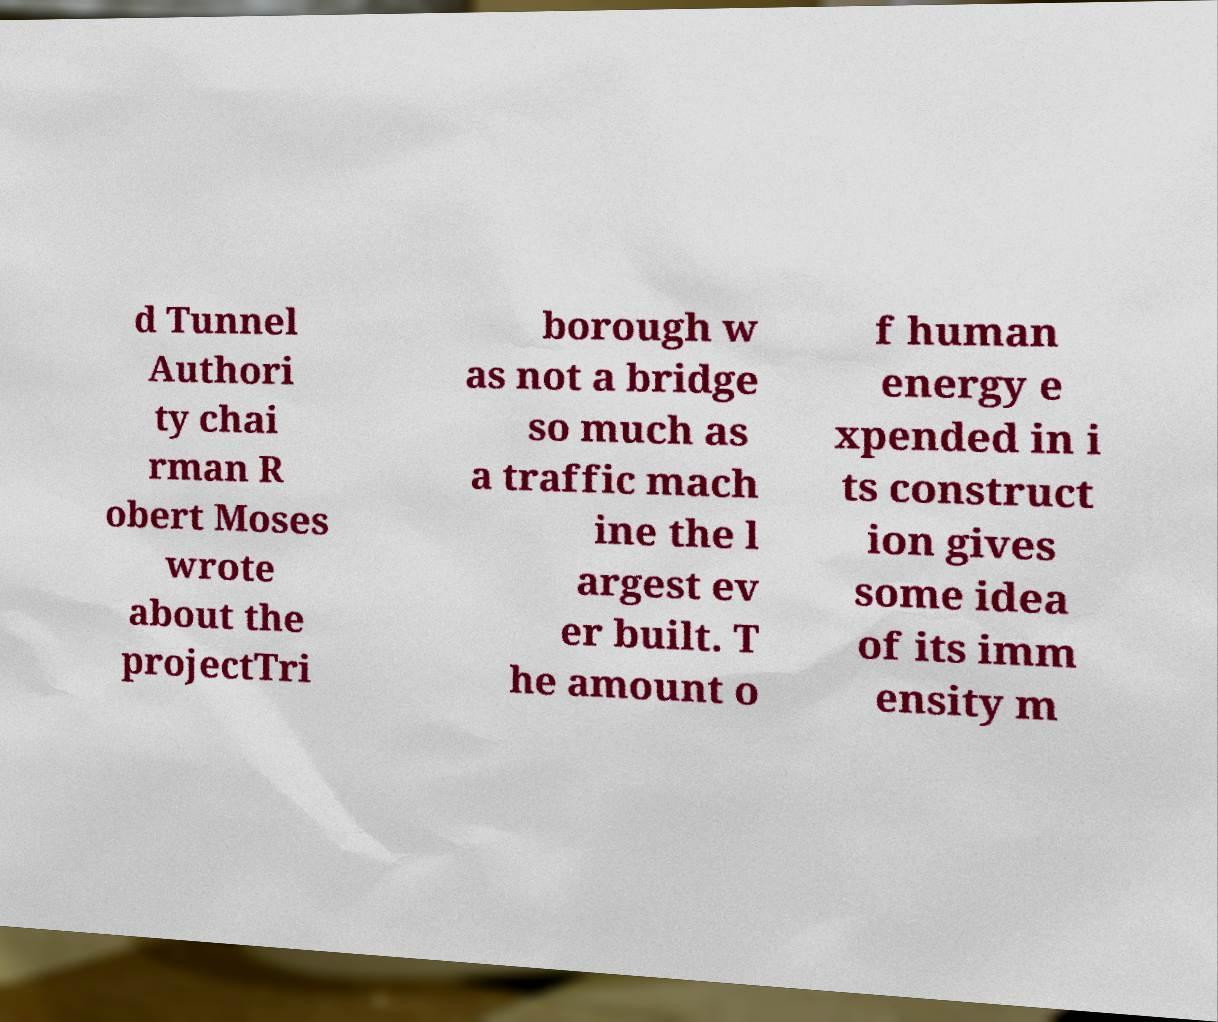There's text embedded in this image that I need extracted. Can you transcribe it verbatim? d Tunnel Authori ty chai rman R obert Moses wrote about the projectTri borough w as not a bridge so much as a traffic mach ine the l argest ev er built. T he amount o f human energy e xpended in i ts construct ion gives some idea of its imm ensity m 